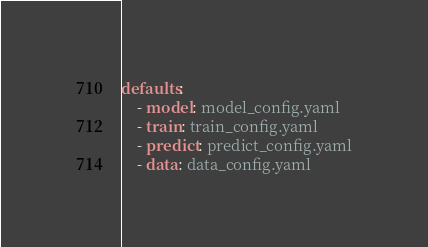Convert code to text. <code><loc_0><loc_0><loc_500><loc_500><_YAML_>defaults:
    - model: model_config.yaml
    - train: train_config.yaml
    - predict: predict_config.yaml
    - data: data_config.yaml
</code> 